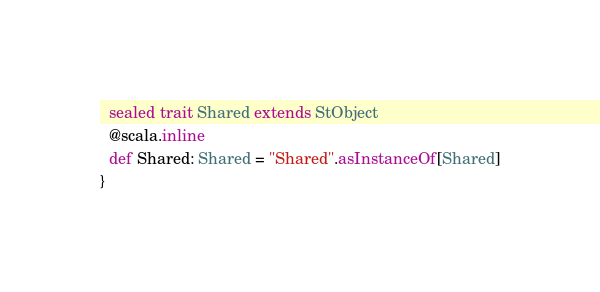Convert code to text. <code><loc_0><loc_0><loc_500><loc_500><_Scala_>  sealed trait Shared extends StObject
  @scala.inline
  def Shared: Shared = "Shared".asInstanceOf[Shared]
}
</code> 